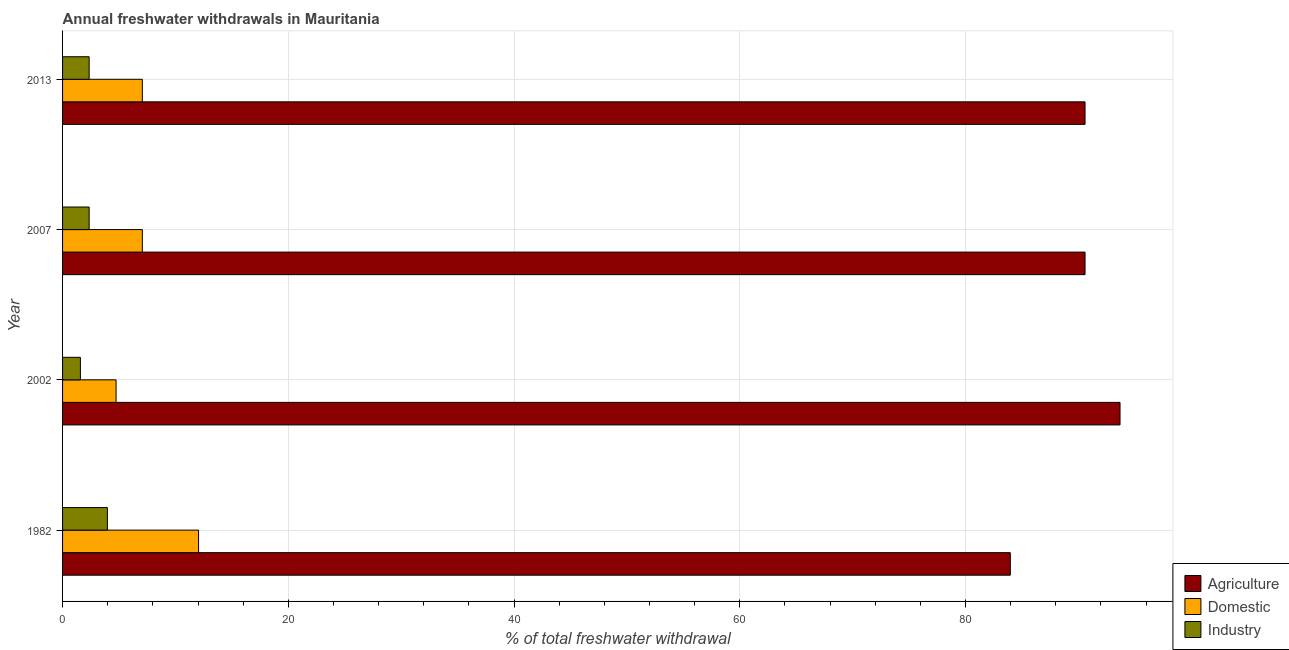How many different coloured bars are there?
Your response must be concise. 3. Are the number of bars per tick equal to the number of legend labels?
Provide a succinct answer. Yes. What is the label of the 2nd group of bars from the top?
Keep it short and to the point. 2007. What is the percentage of freshwater withdrawal for industry in 2007?
Keep it short and to the point. 2.36. Across all years, what is the maximum percentage of freshwater withdrawal for agriculture?
Give a very brief answer. 93.69. Across all years, what is the minimum percentage of freshwater withdrawal for domestic purposes?
Keep it short and to the point. 4.74. In which year was the percentage of freshwater withdrawal for domestic purposes maximum?
Ensure brevity in your answer.  1982. In which year was the percentage of freshwater withdrawal for industry minimum?
Your response must be concise. 2002. What is the total percentage of freshwater withdrawal for industry in the graph?
Ensure brevity in your answer.  10.27. What is the difference between the percentage of freshwater withdrawal for industry in 2002 and that in 2013?
Offer a very short reply. -0.78. What is the difference between the percentage of freshwater withdrawal for domestic purposes in 2002 and the percentage of freshwater withdrawal for industry in 2013?
Your response must be concise. 2.39. What is the average percentage of freshwater withdrawal for domestic purposes per year?
Offer a terse response. 7.73. In the year 2013, what is the difference between the percentage of freshwater withdrawal for domestic purposes and percentage of freshwater withdrawal for industry?
Provide a short and direct response. 4.71. In how many years, is the percentage of freshwater withdrawal for agriculture greater than 12 %?
Ensure brevity in your answer.  4. What is the difference between the highest and the lowest percentage of freshwater withdrawal for domestic purposes?
Provide a short and direct response. 7.31. What does the 2nd bar from the top in 2013 represents?
Your answer should be compact. Domestic. What does the 1st bar from the bottom in 2007 represents?
Your response must be concise. Agriculture. How many bars are there?
Keep it short and to the point. 12. Are all the bars in the graph horizontal?
Provide a short and direct response. Yes. How many years are there in the graph?
Make the answer very short. 4. How many legend labels are there?
Ensure brevity in your answer.  3. How are the legend labels stacked?
Offer a very short reply. Vertical. What is the title of the graph?
Provide a short and direct response. Annual freshwater withdrawals in Mauritania. What is the label or title of the X-axis?
Keep it short and to the point. % of total freshwater withdrawal. What is the label or title of the Y-axis?
Make the answer very short. Year. What is the % of total freshwater withdrawal in Agriculture in 1982?
Make the answer very short. 83.97. What is the % of total freshwater withdrawal of Domestic in 1982?
Ensure brevity in your answer.  12.05. What is the % of total freshwater withdrawal in Industry in 1982?
Give a very brief answer. 3.97. What is the % of total freshwater withdrawal in Agriculture in 2002?
Your response must be concise. 93.69. What is the % of total freshwater withdrawal in Domestic in 2002?
Offer a terse response. 4.74. What is the % of total freshwater withdrawal in Industry in 2002?
Offer a very short reply. 1.58. What is the % of total freshwater withdrawal of Agriculture in 2007?
Your answer should be very brief. 90.59. What is the % of total freshwater withdrawal of Domestic in 2007?
Your answer should be very brief. 7.07. What is the % of total freshwater withdrawal in Industry in 2007?
Offer a very short reply. 2.36. What is the % of total freshwater withdrawal in Agriculture in 2013?
Your answer should be compact. 90.59. What is the % of total freshwater withdrawal of Domestic in 2013?
Provide a succinct answer. 7.07. What is the % of total freshwater withdrawal in Industry in 2013?
Your answer should be compact. 2.36. Across all years, what is the maximum % of total freshwater withdrawal in Agriculture?
Provide a succinct answer. 93.69. Across all years, what is the maximum % of total freshwater withdrawal of Domestic?
Your response must be concise. 12.05. Across all years, what is the maximum % of total freshwater withdrawal of Industry?
Provide a succinct answer. 3.97. Across all years, what is the minimum % of total freshwater withdrawal of Agriculture?
Ensure brevity in your answer.  83.97. Across all years, what is the minimum % of total freshwater withdrawal in Domestic?
Ensure brevity in your answer.  4.74. Across all years, what is the minimum % of total freshwater withdrawal in Industry?
Provide a short and direct response. 1.58. What is the total % of total freshwater withdrawal in Agriculture in the graph?
Offer a very short reply. 358.84. What is the total % of total freshwater withdrawal of Domestic in the graph?
Your answer should be compact. 30.93. What is the total % of total freshwater withdrawal in Industry in the graph?
Give a very brief answer. 10.27. What is the difference between the % of total freshwater withdrawal in Agriculture in 1982 and that in 2002?
Keep it short and to the point. -9.72. What is the difference between the % of total freshwater withdrawal in Domestic in 1982 and that in 2002?
Offer a terse response. 7.31. What is the difference between the % of total freshwater withdrawal of Industry in 1982 and that in 2002?
Your response must be concise. 2.39. What is the difference between the % of total freshwater withdrawal in Agriculture in 1982 and that in 2007?
Your answer should be very brief. -6.62. What is the difference between the % of total freshwater withdrawal of Domestic in 1982 and that in 2007?
Offer a terse response. 4.98. What is the difference between the % of total freshwater withdrawal in Industry in 1982 and that in 2007?
Your response must be concise. 1.62. What is the difference between the % of total freshwater withdrawal of Agriculture in 1982 and that in 2013?
Your answer should be compact. -6.62. What is the difference between the % of total freshwater withdrawal in Domestic in 1982 and that in 2013?
Provide a succinct answer. 4.98. What is the difference between the % of total freshwater withdrawal of Industry in 1982 and that in 2013?
Provide a succinct answer. 1.62. What is the difference between the % of total freshwater withdrawal in Agriculture in 2002 and that in 2007?
Ensure brevity in your answer.  3.1. What is the difference between the % of total freshwater withdrawal in Domestic in 2002 and that in 2007?
Your response must be concise. -2.33. What is the difference between the % of total freshwater withdrawal of Industry in 2002 and that in 2007?
Your response must be concise. -0.78. What is the difference between the % of total freshwater withdrawal of Domestic in 2002 and that in 2013?
Offer a terse response. -2.33. What is the difference between the % of total freshwater withdrawal in Industry in 2002 and that in 2013?
Provide a succinct answer. -0.78. What is the difference between the % of total freshwater withdrawal in Domestic in 2007 and that in 2013?
Keep it short and to the point. 0. What is the difference between the % of total freshwater withdrawal in Agriculture in 1982 and the % of total freshwater withdrawal in Domestic in 2002?
Provide a succinct answer. 79.23. What is the difference between the % of total freshwater withdrawal in Agriculture in 1982 and the % of total freshwater withdrawal in Industry in 2002?
Offer a terse response. 82.39. What is the difference between the % of total freshwater withdrawal of Domestic in 1982 and the % of total freshwater withdrawal of Industry in 2002?
Offer a terse response. 10.47. What is the difference between the % of total freshwater withdrawal of Agriculture in 1982 and the % of total freshwater withdrawal of Domestic in 2007?
Offer a very short reply. 76.9. What is the difference between the % of total freshwater withdrawal in Agriculture in 1982 and the % of total freshwater withdrawal in Industry in 2007?
Offer a very short reply. 81.61. What is the difference between the % of total freshwater withdrawal in Domestic in 1982 and the % of total freshwater withdrawal in Industry in 2007?
Make the answer very short. 9.69. What is the difference between the % of total freshwater withdrawal of Agriculture in 1982 and the % of total freshwater withdrawal of Domestic in 2013?
Your answer should be compact. 76.9. What is the difference between the % of total freshwater withdrawal of Agriculture in 1982 and the % of total freshwater withdrawal of Industry in 2013?
Provide a succinct answer. 81.61. What is the difference between the % of total freshwater withdrawal in Domestic in 1982 and the % of total freshwater withdrawal in Industry in 2013?
Your answer should be compact. 9.69. What is the difference between the % of total freshwater withdrawal of Agriculture in 2002 and the % of total freshwater withdrawal of Domestic in 2007?
Offer a very short reply. 86.62. What is the difference between the % of total freshwater withdrawal in Agriculture in 2002 and the % of total freshwater withdrawal in Industry in 2007?
Your response must be concise. 91.33. What is the difference between the % of total freshwater withdrawal in Domestic in 2002 and the % of total freshwater withdrawal in Industry in 2007?
Provide a short and direct response. 2.38. What is the difference between the % of total freshwater withdrawal of Agriculture in 2002 and the % of total freshwater withdrawal of Domestic in 2013?
Give a very brief answer. 86.62. What is the difference between the % of total freshwater withdrawal of Agriculture in 2002 and the % of total freshwater withdrawal of Industry in 2013?
Give a very brief answer. 91.33. What is the difference between the % of total freshwater withdrawal in Domestic in 2002 and the % of total freshwater withdrawal in Industry in 2013?
Provide a short and direct response. 2.38. What is the difference between the % of total freshwater withdrawal in Agriculture in 2007 and the % of total freshwater withdrawal in Domestic in 2013?
Give a very brief answer. 83.52. What is the difference between the % of total freshwater withdrawal in Agriculture in 2007 and the % of total freshwater withdrawal in Industry in 2013?
Provide a succinct answer. 88.23. What is the difference between the % of total freshwater withdrawal of Domestic in 2007 and the % of total freshwater withdrawal of Industry in 2013?
Keep it short and to the point. 4.71. What is the average % of total freshwater withdrawal of Agriculture per year?
Provide a succinct answer. 89.71. What is the average % of total freshwater withdrawal in Domestic per year?
Your answer should be very brief. 7.73. What is the average % of total freshwater withdrawal in Industry per year?
Offer a terse response. 2.57. In the year 1982, what is the difference between the % of total freshwater withdrawal in Agriculture and % of total freshwater withdrawal in Domestic?
Your answer should be compact. 71.92. In the year 1982, what is the difference between the % of total freshwater withdrawal of Agriculture and % of total freshwater withdrawal of Industry?
Keep it short and to the point. 80. In the year 1982, what is the difference between the % of total freshwater withdrawal of Domestic and % of total freshwater withdrawal of Industry?
Keep it short and to the point. 8.08. In the year 2002, what is the difference between the % of total freshwater withdrawal in Agriculture and % of total freshwater withdrawal in Domestic?
Your answer should be compact. 88.95. In the year 2002, what is the difference between the % of total freshwater withdrawal of Agriculture and % of total freshwater withdrawal of Industry?
Keep it short and to the point. 92.11. In the year 2002, what is the difference between the % of total freshwater withdrawal of Domestic and % of total freshwater withdrawal of Industry?
Make the answer very short. 3.16. In the year 2007, what is the difference between the % of total freshwater withdrawal in Agriculture and % of total freshwater withdrawal in Domestic?
Your response must be concise. 83.52. In the year 2007, what is the difference between the % of total freshwater withdrawal of Agriculture and % of total freshwater withdrawal of Industry?
Provide a succinct answer. 88.23. In the year 2007, what is the difference between the % of total freshwater withdrawal in Domestic and % of total freshwater withdrawal in Industry?
Provide a short and direct response. 4.71. In the year 2013, what is the difference between the % of total freshwater withdrawal in Agriculture and % of total freshwater withdrawal in Domestic?
Provide a short and direct response. 83.52. In the year 2013, what is the difference between the % of total freshwater withdrawal of Agriculture and % of total freshwater withdrawal of Industry?
Your answer should be compact. 88.23. In the year 2013, what is the difference between the % of total freshwater withdrawal of Domestic and % of total freshwater withdrawal of Industry?
Ensure brevity in your answer.  4.71. What is the ratio of the % of total freshwater withdrawal of Agriculture in 1982 to that in 2002?
Your answer should be very brief. 0.9. What is the ratio of the % of total freshwater withdrawal of Domestic in 1982 to that in 2002?
Ensure brevity in your answer.  2.54. What is the ratio of the % of total freshwater withdrawal in Industry in 1982 to that in 2002?
Offer a terse response. 2.51. What is the ratio of the % of total freshwater withdrawal of Agriculture in 1982 to that in 2007?
Keep it short and to the point. 0.93. What is the ratio of the % of total freshwater withdrawal in Domestic in 1982 to that in 2007?
Your response must be concise. 1.71. What is the ratio of the % of total freshwater withdrawal in Industry in 1982 to that in 2007?
Make the answer very short. 1.69. What is the ratio of the % of total freshwater withdrawal of Agriculture in 1982 to that in 2013?
Your answer should be very brief. 0.93. What is the ratio of the % of total freshwater withdrawal of Domestic in 1982 to that in 2013?
Keep it short and to the point. 1.71. What is the ratio of the % of total freshwater withdrawal of Industry in 1982 to that in 2013?
Ensure brevity in your answer.  1.69. What is the ratio of the % of total freshwater withdrawal in Agriculture in 2002 to that in 2007?
Give a very brief answer. 1.03. What is the ratio of the % of total freshwater withdrawal in Domestic in 2002 to that in 2007?
Offer a very short reply. 0.67. What is the ratio of the % of total freshwater withdrawal in Industry in 2002 to that in 2007?
Ensure brevity in your answer.  0.67. What is the ratio of the % of total freshwater withdrawal of Agriculture in 2002 to that in 2013?
Give a very brief answer. 1.03. What is the ratio of the % of total freshwater withdrawal of Domestic in 2002 to that in 2013?
Offer a terse response. 0.67. What is the ratio of the % of total freshwater withdrawal of Industry in 2002 to that in 2013?
Offer a terse response. 0.67. What is the ratio of the % of total freshwater withdrawal of Agriculture in 2007 to that in 2013?
Give a very brief answer. 1. What is the difference between the highest and the second highest % of total freshwater withdrawal in Agriculture?
Your answer should be compact. 3.1. What is the difference between the highest and the second highest % of total freshwater withdrawal in Domestic?
Your answer should be compact. 4.98. What is the difference between the highest and the second highest % of total freshwater withdrawal of Industry?
Keep it short and to the point. 1.62. What is the difference between the highest and the lowest % of total freshwater withdrawal in Agriculture?
Give a very brief answer. 9.72. What is the difference between the highest and the lowest % of total freshwater withdrawal of Domestic?
Your answer should be very brief. 7.31. What is the difference between the highest and the lowest % of total freshwater withdrawal in Industry?
Provide a short and direct response. 2.39. 